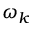Convert formula to latex. <formula><loc_0><loc_0><loc_500><loc_500>\omega _ { k }</formula> 